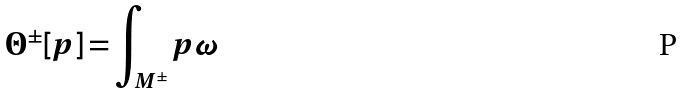<formula> <loc_0><loc_0><loc_500><loc_500>\Theta ^ { \pm } [ p ] = \int _ { M ^ { \pm } } { p \omega }</formula> 